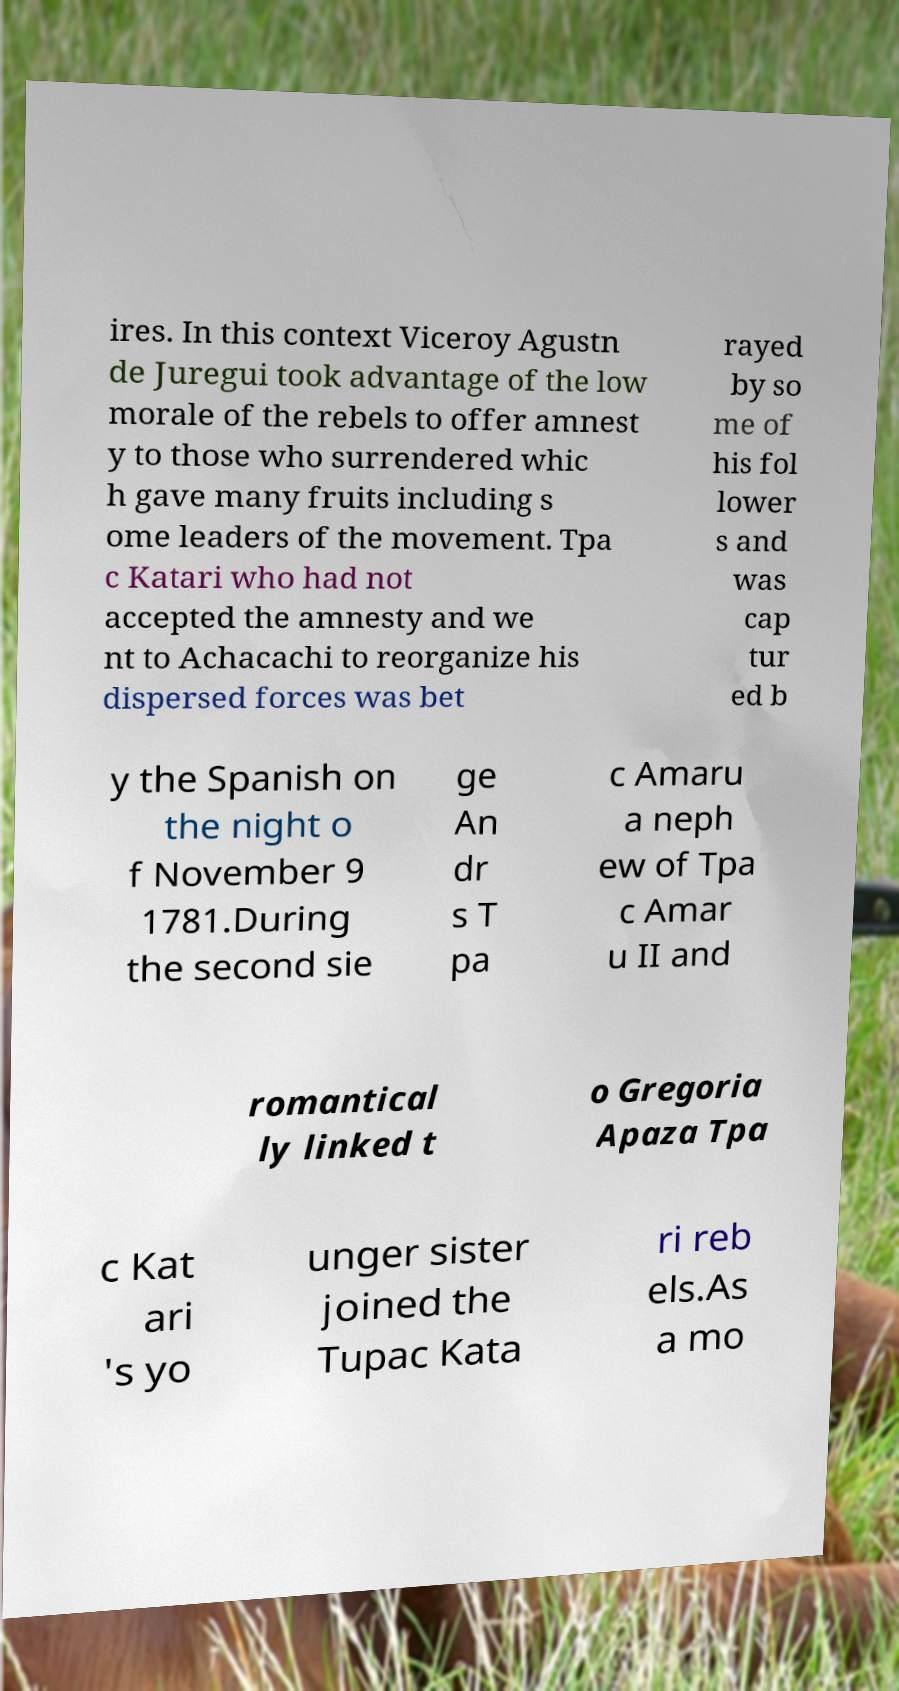Can you read and provide the text displayed in the image?This photo seems to have some interesting text. Can you extract and type it out for me? ires. In this context Viceroy Agustn de Juregui took advantage of the low morale of the rebels to offer amnest y to those who surrendered whic h gave many fruits including s ome leaders of the movement. Tpa c Katari who had not accepted the amnesty and we nt to Achacachi to reorganize his dispersed forces was bet rayed by so me of his fol lower s and was cap tur ed b y the Spanish on the night o f November 9 1781.During the second sie ge An dr s T pa c Amaru a neph ew of Tpa c Amar u II and romantical ly linked t o Gregoria Apaza Tpa c Kat ari 's yo unger sister joined the Tupac Kata ri reb els.As a mo 